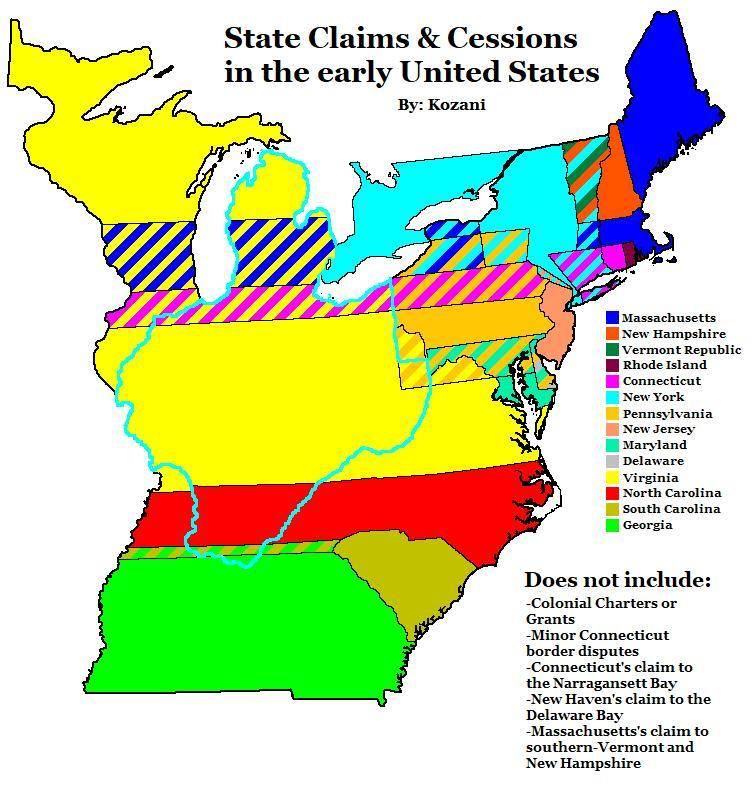Which color is used to represent North Carolina - red, blue or green?
Answer the question with a short phrase. red 